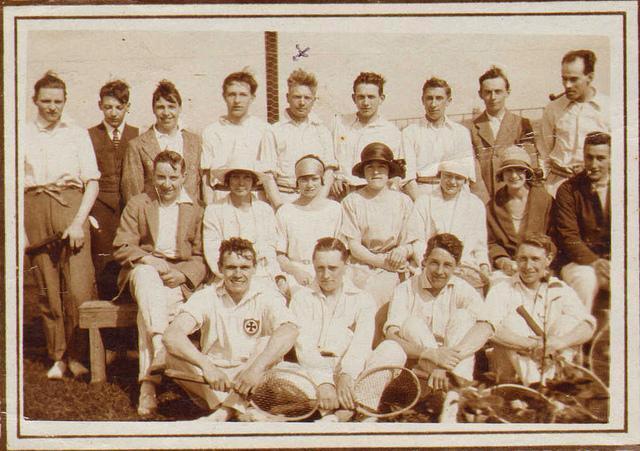How many people are standing?
Give a very brief answer. 9. How many people are in the picture?
Give a very brief answer. 14. How many tennis rackets are there?
Give a very brief answer. 2. 